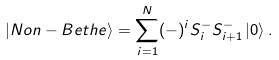<formula> <loc_0><loc_0><loc_500><loc_500>\left | N o n - B e t h e \right > = \sum _ { i = 1 } ^ { N } ( - ) ^ { i } S _ { i } ^ { - } S _ { i + 1 } ^ { - } \left | 0 \right > .</formula> 